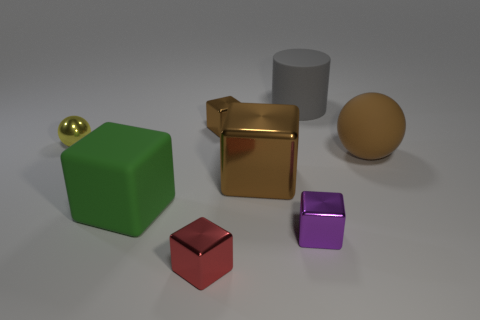What possible uses could these objects have? These objects might be used for various purposes, such as educational aids for teaching geometry, materials for a still life drawing class, or elements in a 3D modeling and rendering software tutorial. Is there anything interesting about the lighting or arrangement of the objects? The lighting appears to be diffuse, softening the shadows and giving the scene a calm, measured ambiance. The arrangement of objects is methodical, with spaces between them that provide a clear view and create a sense of order. 